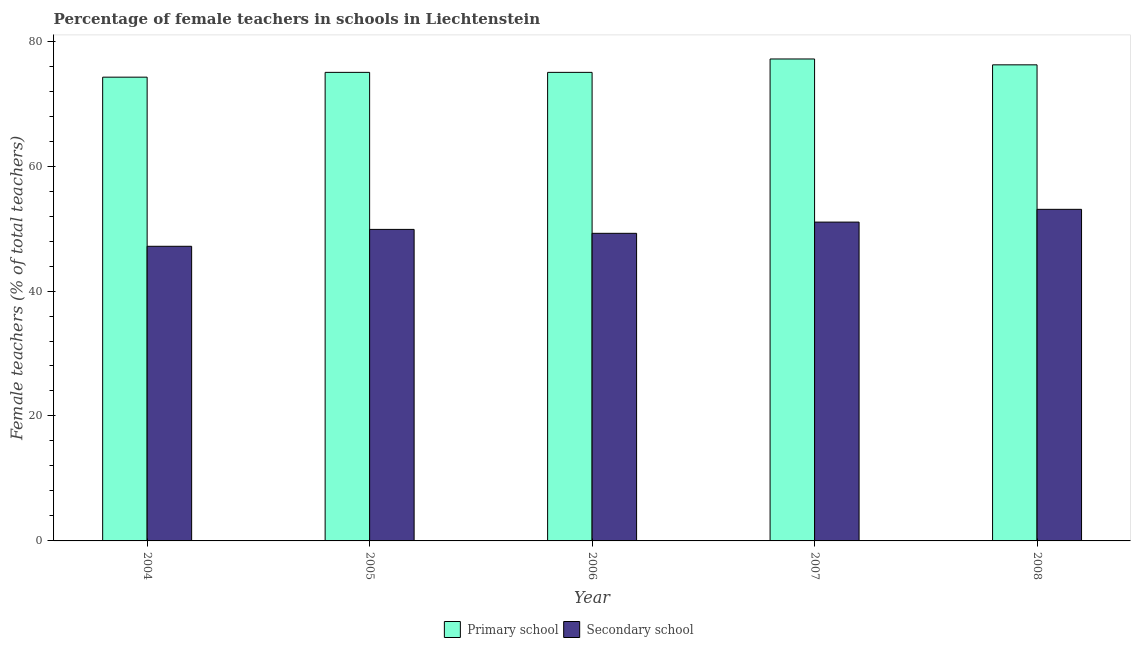How many different coloured bars are there?
Ensure brevity in your answer.  2. Are the number of bars per tick equal to the number of legend labels?
Make the answer very short. Yes. What is the percentage of female teachers in primary schools in 2006?
Make the answer very short. 75. Across all years, what is the maximum percentage of female teachers in secondary schools?
Give a very brief answer. 53.07. Across all years, what is the minimum percentage of female teachers in secondary schools?
Give a very brief answer. 47.16. In which year was the percentage of female teachers in primary schools maximum?
Your answer should be compact. 2007. In which year was the percentage of female teachers in primary schools minimum?
Your answer should be very brief. 2004. What is the total percentage of female teachers in secondary schools in the graph?
Provide a succinct answer. 250.37. What is the difference between the percentage of female teachers in secondary schools in 2005 and that in 2008?
Offer a terse response. -3.21. What is the difference between the percentage of female teachers in secondary schools in 2008 and the percentage of female teachers in primary schools in 2004?
Provide a succinct answer. 5.92. What is the average percentage of female teachers in primary schools per year?
Your response must be concise. 75.52. What is the ratio of the percentage of female teachers in secondary schools in 2006 to that in 2008?
Your answer should be compact. 0.93. Is the percentage of female teachers in secondary schools in 2004 less than that in 2007?
Your response must be concise. Yes. Is the difference between the percentage of female teachers in secondary schools in 2005 and 2006 greater than the difference between the percentage of female teachers in primary schools in 2005 and 2006?
Offer a terse response. No. What is the difference between the highest and the second highest percentage of female teachers in secondary schools?
Provide a succinct answer. 2.04. What is the difference between the highest and the lowest percentage of female teachers in secondary schools?
Provide a short and direct response. 5.92. In how many years, is the percentage of female teachers in primary schools greater than the average percentage of female teachers in primary schools taken over all years?
Make the answer very short. 2. What does the 1st bar from the left in 2005 represents?
Your response must be concise. Primary school. What does the 1st bar from the right in 2006 represents?
Give a very brief answer. Secondary school. Are the values on the major ticks of Y-axis written in scientific E-notation?
Your response must be concise. No. How are the legend labels stacked?
Provide a succinct answer. Horizontal. What is the title of the graph?
Offer a terse response. Percentage of female teachers in schools in Liechtenstein. Does "Mineral" appear as one of the legend labels in the graph?
Ensure brevity in your answer.  No. What is the label or title of the Y-axis?
Offer a very short reply. Female teachers (% of total teachers). What is the Female teachers (% of total teachers) in Primary school in 2004?
Your answer should be compact. 74.23. What is the Female teachers (% of total teachers) of Secondary school in 2004?
Your response must be concise. 47.16. What is the Female teachers (% of total teachers) in Secondary school in 2005?
Your answer should be compact. 49.86. What is the Female teachers (% of total teachers) of Primary school in 2006?
Your answer should be very brief. 75. What is the Female teachers (% of total teachers) in Secondary school in 2006?
Your answer should be very brief. 49.24. What is the Female teachers (% of total teachers) of Primary school in 2007?
Your answer should be compact. 77.14. What is the Female teachers (% of total teachers) of Secondary school in 2007?
Ensure brevity in your answer.  51.03. What is the Female teachers (% of total teachers) in Primary school in 2008?
Ensure brevity in your answer.  76.2. What is the Female teachers (% of total teachers) in Secondary school in 2008?
Your answer should be very brief. 53.07. Across all years, what is the maximum Female teachers (% of total teachers) in Primary school?
Offer a terse response. 77.14. Across all years, what is the maximum Female teachers (% of total teachers) of Secondary school?
Provide a short and direct response. 53.07. Across all years, what is the minimum Female teachers (% of total teachers) in Primary school?
Make the answer very short. 74.23. Across all years, what is the minimum Female teachers (% of total teachers) of Secondary school?
Your response must be concise. 47.16. What is the total Female teachers (% of total teachers) in Primary school in the graph?
Make the answer very short. 377.58. What is the total Female teachers (% of total teachers) of Secondary school in the graph?
Provide a succinct answer. 250.37. What is the difference between the Female teachers (% of total teachers) in Primary school in 2004 and that in 2005?
Give a very brief answer. -0.77. What is the difference between the Female teachers (% of total teachers) of Secondary school in 2004 and that in 2005?
Offer a terse response. -2.71. What is the difference between the Female teachers (% of total teachers) in Primary school in 2004 and that in 2006?
Offer a terse response. -0.77. What is the difference between the Female teachers (% of total teachers) in Secondary school in 2004 and that in 2006?
Your response must be concise. -2.08. What is the difference between the Female teachers (% of total teachers) in Primary school in 2004 and that in 2007?
Offer a very short reply. -2.91. What is the difference between the Female teachers (% of total teachers) of Secondary school in 2004 and that in 2007?
Give a very brief answer. -3.87. What is the difference between the Female teachers (% of total teachers) of Primary school in 2004 and that in 2008?
Keep it short and to the point. -1.97. What is the difference between the Female teachers (% of total teachers) of Secondary school in 2004 and that in 2008?
Provide a succinct answer. -5.92. What is the difference between the Female teachers (% of total teachers) in Secondary school in 2005 and that in 2006?
Make the answer very short. 0.63. What is the difference between the Female teachers (% of total teachers) in Primary school in 2005 and that in 2007?
Your response must be concise. -2.14. What is the difference between the Female teachers (% of total teachers) of Secondary school in 2005 and that in 2007?
Provide a short and direct response. -1.17. What is the difference between the Female teachers (% of total teachers) of Primary school in 2005 and that in 2008?
Offer a very short reply. -1.2. What is the difference between the Female teachers (% of total teachers) in Secondary school in 2005 and that in 2008?
Your answer should be compact. -3.21. What is the difference between the Female teachers (% of total teachers) in Primary school in 2006 and that in 2007?
Your answer should be very brief. -2.14. What is the difference between the Female teachers (% of total teachers) in Secondary school in 2006 and that in 2007?
Give a very brief answer. -1.8. What is the difference between the Female teachers (% of total teachers) in Primary school in 2006 and that in 2008?
Provide a short and direct response. -1.2. What is the difference between the Female teachers (% of total teachers) in Secondary school in 2006 and that in 2008?
Give a very brief answer. -3.84. What is the difference between the Female teachers (% of total teachers) of Primary school in 2007 and that in 2008?
Your answer should be compact. 0.94. What is the difference between the Female teachers (% of total teachers) of Secondary school in 2007 and that in 2008?
Provide a succinct answer. -2.04. What is the difference between the Female teachers (% of total teachers) of Primary school in 2004 and the Female teachers (% of total teachers) of Secondary school in 2005?
Your response must be concise. 24.37. What is the difference between the Female teachers (% of total teachers) of Primary school in 2004 and the Female teachers (% of total teachers) of Secondary school in 2006?
Give a very brief answer. 25. What is the difference between the Female teachers (% of total teachers) in Primary school in 2004 and the Female teachers (% of total teachers) in Secondary school in 2007?
Provide a short and direct response. 23.2. What is the difference between the Female teachers (% of total teachers) in Primary school in 2004 and the Female teachers (% of total teachers) in Secondary school in 2008?
Your response must be concise. 21.16. What is the difference between the Female teachers (% of total teachers) in Primary school in 2005 and the Female teachers (% of total teachers) in Secondary school in 2006?
Your answer should be compact. 25.76. What is the difference between the Female teachers (% of total teachers) in Primary school in 2005 and the Female teachers (% of total teachers) in Secondary school in 2007?
Your answer should be very brief. 23.97. What is the difference between the Female teachers (% of total teachers) of Primary school in 2005 and the Female teachers (% of total teachers) of Secondary school in 2008?
Ensure brevity in your answer.  21.93. What is the difference between the Female teachers (% of total teachers) in Primary school in 2006 and the Female teachers (% of total teachers) in Secondary school in 2007?
Provide a short and direct response. 23.97. What is the difference between the Female teachers (% of total teachers) of Primary school in 2006 and the Female teachers (% of total teachers) of Secondary school in 2008?
Ensure brevity in your answer.  21.93. What is the difference between the Female teachers (% of total teachers) of Primary school in 2007 and the Female teachers (% of total teachers) of Secondary school in 2008?
Offer a very short reply. 24.07. What is the average Female teachers (% of total teachers) in Primary school per year?
Offer a terse response. 75.52. What is the average Female teachers (% of total teachers) of Secondary school per year?
Give a very brief answer. 50.07. In the year 2004, what is the difference between the Female teachers (% of total teachers) of Primary school and Female teachers (% of total teachers) of Secondary school?
Provide a short and direct response. 27.07. In the year 2005, what is the difference between the Female teachers (% of total teachers) of Primary school and Female teachers (% of total teachers) of Secondary school?
Give a very brief answer. 25.14. In the year 2006, what is the difference between the Female teachers (% of total teachers) in Primary school and Female teachers (% of total teachers) in Secondary school?
Offer a very short reply. 25.76. In the year 2007, what is the difference between the Female teachers (% of total teachers) of Primary school and Female teachers (% of total teachers) of Secondary school?
Provide a short and direct response. 26.11. In the year 2008, what is the difference between the Female teachers (% of total teachers) of Primary school and Female teachers (% of total teachers) of Secondary school?
Keep it short and to the point. 23.13. What is the ratio of the Female teachers (% of total teachers) of Primary school in 2004 to that in 2005?
Provide a short and direct response. 0.99. What is the ratio of the Female teachers (% of total teachers) in Secondary school in 2004 to that in 2005?
Give a very brief answer. 0.95. What is the ratio of the Female teachers (% of total teachers) of Primary school in 2004 to that in 2006?
Your answer should be very brief. 0.99. What is the ratio of the Female teachers (% of total teachers) of Secondary school in 2004 to that in 2006?
Keep it short and to the point. 0.96. What is the ratio of the Female teachers (% of total teachers) of Primary school in 2004 to that in 2007?
Ensure brevity in your answer.  0.96. What is the ratio of the Female teachers (% of total teachers) in Secondary school in 2004 to that in 2007?
Your answer should be very brief. 0.92. What is the ratio of the Female teachers (% of total teachers) of Primary school in 2004 to that in 2008?
Offer a very short reply. 0.97. What is the ratio of the Female teachers (% of total teachers) of Secondary school in 2004 to that in 2008?
Offer a terse response. 0.89. What is the ratio of the Female teachers (% of total teachers) of Primary school in 2005 to that in 2006?
Keep it short and to the point. 1. What is the ratio of the Female teachers (% of total teachers) of Secondary school in 2005 to that in 2006?
Give a very brief answer. 1.01. What is the ratio of the Female teachers (% of total teachers) of Primary school in 2005 to that in 2007?
Give a very brief answer. 0.97. What is the ratio of the Female teachers (% of total teachers) of Secondary school in 2005 to that in 2007?
Your response must be concise. 0.98. What is the ratio of the Female teachers (% of total teachers) in Primary school in 2005 to that in 2008?
Provide a succinct answer. 0.98. What is the ratio of the Female teachers (% of total teachers) of Secondary school in 2005 to that in 2008?
Provide a short and direct response. 0.94. What is the ratio of the Female teachers (% of total teachers) in Primary school in 2006 to that in 2007?
Your answer should be very brief. 0.97. What is the ratio of the Female teachers (% of total teachers) of Secondary school in 2006 to that in 2007?
Ensure brevity in your answer.  0.96. What is the ratio of the Female teachers (% of total teachers) in Primary school in 2006 to that in 2008?
Keep it short and to the point. 0.98. What is the ratio of the Female teachers (% of total teachers) in Secondary school in 2006 to that in 2008?
Offer a terse response. 0.93. What is the ratio of the Female teachers (% of total teachers) in Primary school in 2007 to that in 2008?
Your answer should be compact. 1.01. What is the ratio of the Female teachers (% of total teachers) of Secondary school in 2007 to that in 2008?
Offer a terse response. 0.96. What is the difference between the highest and the second highest Female teachers (% of total teachers) in Primary school?
Make the answer very short. 0.94. What is the difference between the highest and the second highest Female teachers (% of total teachers) of Secondary school?
Ensure brevity in your answer.  2.04. What is the difference between the highest and the lowest Female teachers (% of total teachers) in Primary school?
Your response must be concise. 2.91. What is the difference between the highest and the lowest Female teachers (% of total teachers) of Secondary school?
Your response must be concise. 5.92. 